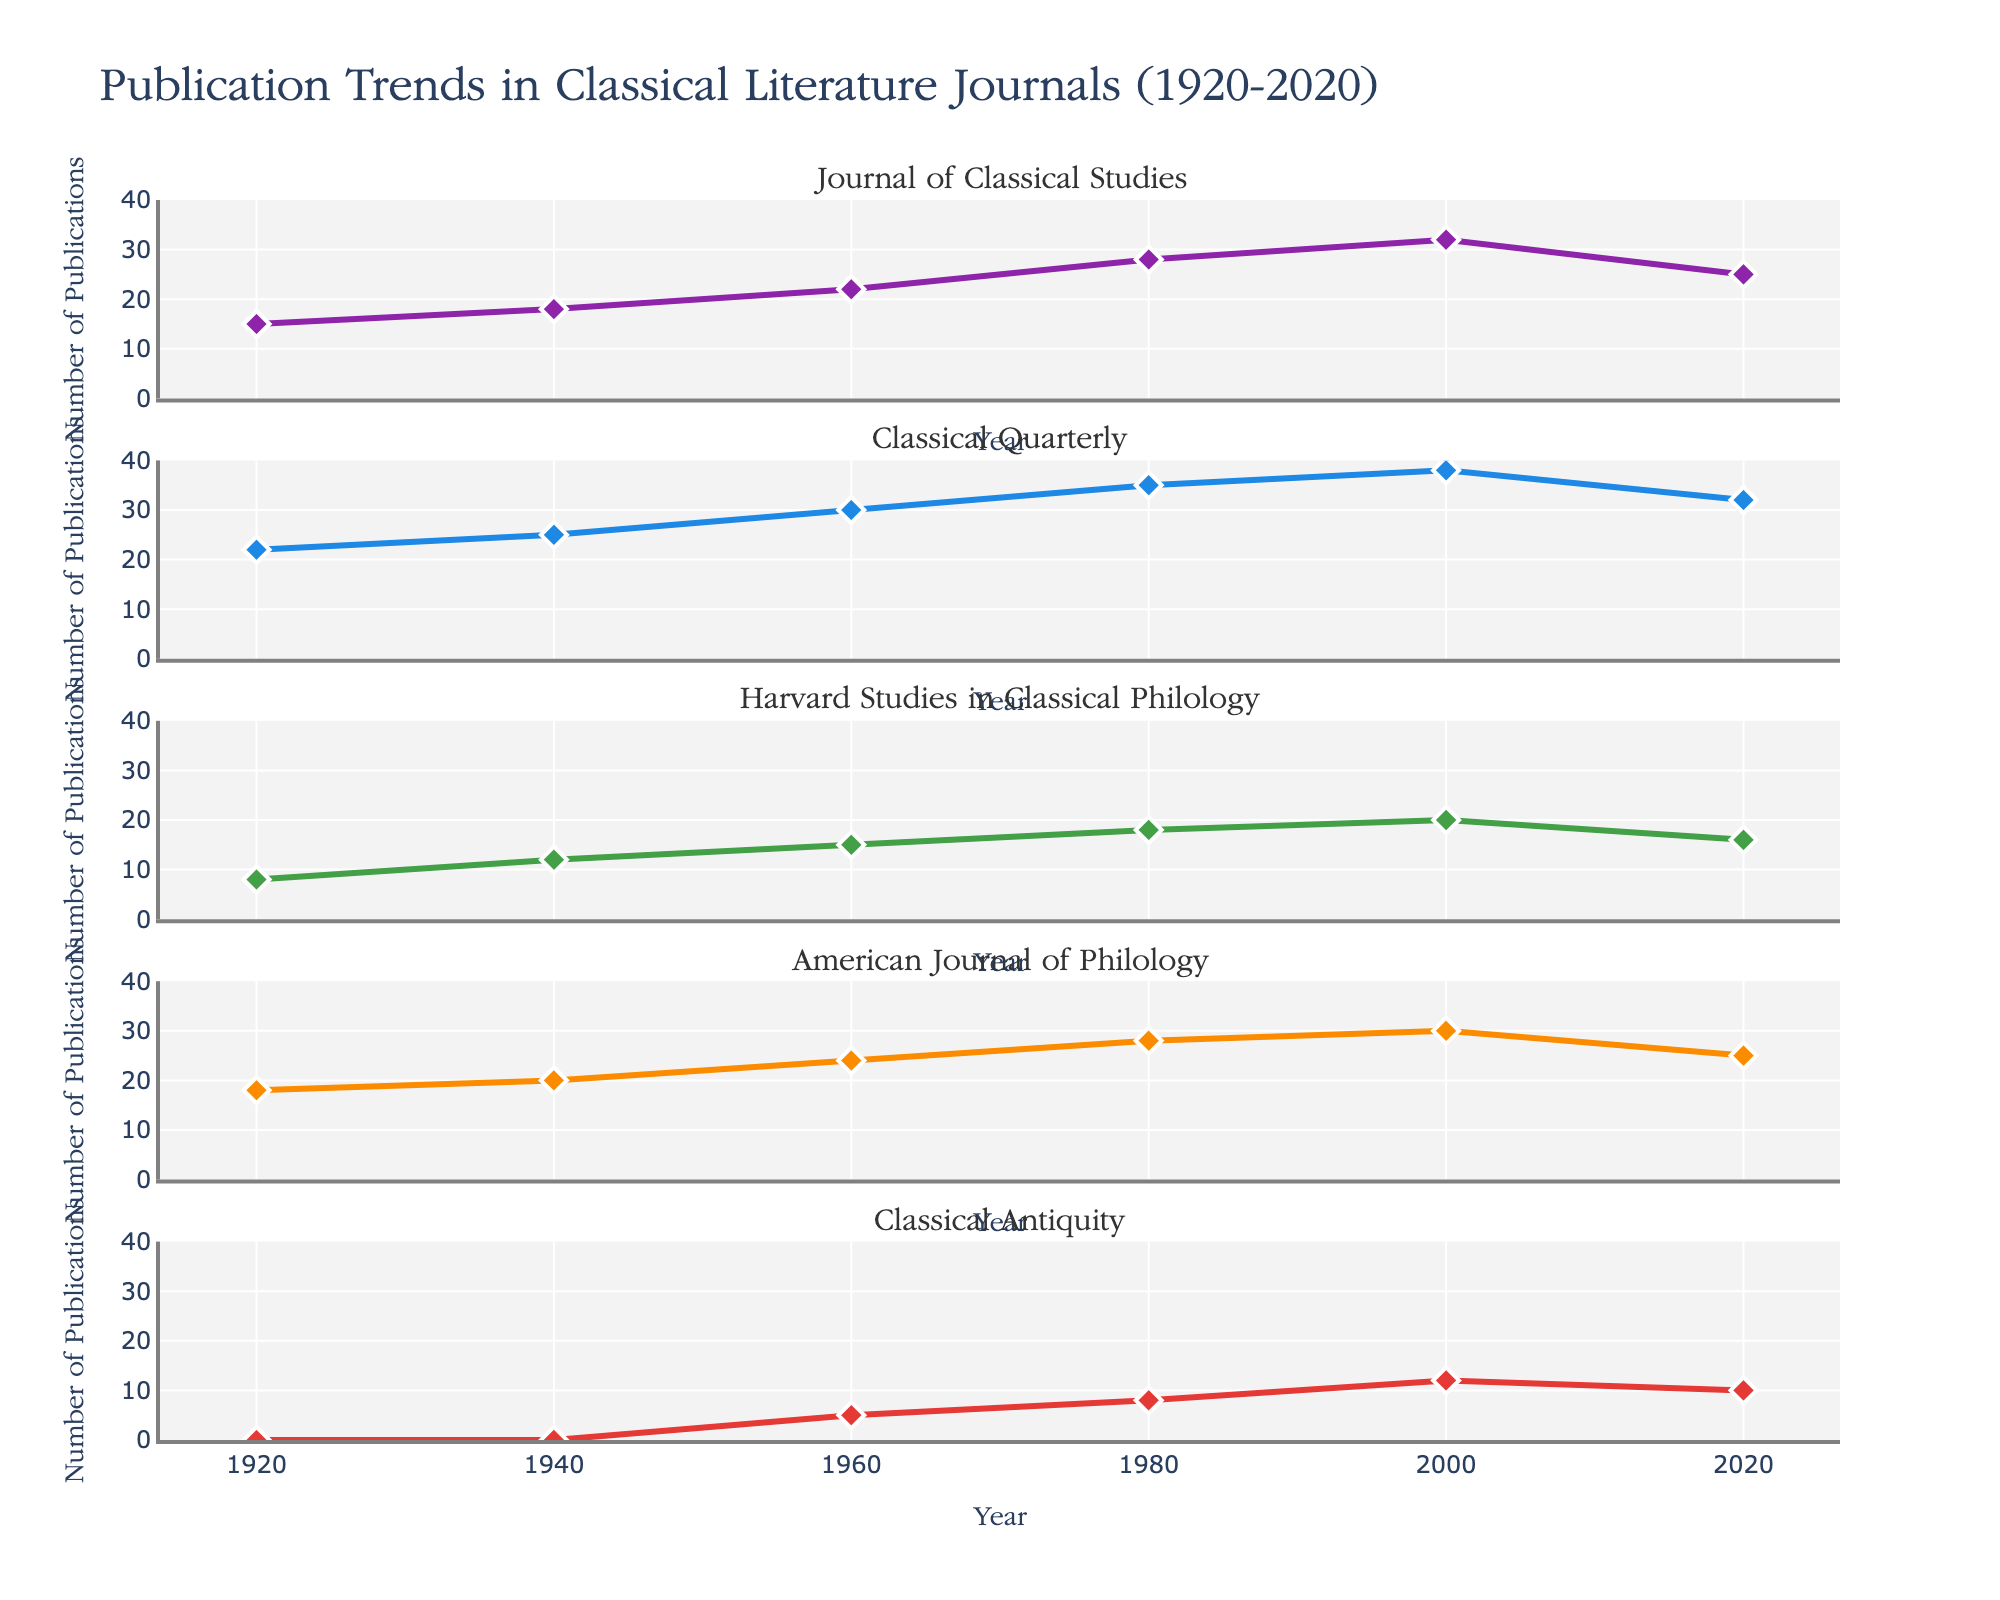what is the title of the figure? The title can be found at the top of the figure, where it usually provides a summary of the visualized data.
Answer: Burke Family Occupations Across Generations How many different occupations are represented in the 1st Generation? The pie chart representing the 1st Generation shows various slices, each corresponding to a distinct occupation. By counting these slices, we can determine the number of occupations.
Answer: 4 Which generation has the highest percentage of a single occupation? To identify which generation has the highest percentage of a single occupation, compare the largest segment in both the pie chart and the other subplot types for each generation. The pie chart of the 1st Generation shows that the Farmer occupation has the highest percentage among all generations.
Answer: 1st Generation What is the sum of the counts of occupations for the 3rd Generation? By summing up the 'Count' values for all occupations represented in the scatter plot for the 3rd Generation, we can get the total. The counts are 7 + 4 + 3 + 3 + 2 + 1.
Answer: 20 What are the two occupations with equal counts in the 3rd Generation? The scatter plot of the 3rd Generation shows points that can be examined for their y-values (counts). The occupations with equal y-values of 3 can be identified.
Answer: Engineer and Accountant Which profession is most common in the 2nd Generation? In the bar plot for the 2nd Generation, the height of the bars corresponds to the 'Count'. The tallest bar indicates the most common profession.
Answer: Farmer In the 4th Generation, which occupation has the second-highest count? The treemap for the 4th Generation displays the sizes of rectangles corresponding to counts. The second-largest rectangle indicates the occupation.
Answer: Marketing Manager Compare the number of occupations between the 1st and 4th Generations. Which generation has more? By counting the distinct occupations shown in the pie chart for the 1st Generation and the treemap for the 4th Generation, we can determine the difference. The 1st Generation has 4 occupations, and the 4th Generation has 6.
Answer: 4th Generation Which generation has the largest variety of occupations? To find the generation with the largest variety, count the number of distinct occupations for each generation presented in the various subplot types (pie, bar, scatter, treemap).
Answer: 4th Generation What percentage of the 3rd Generation are Civil Servants? Referring to the scatter plot for the 3rd Generation, the 'Count' of Civil Servants and the total count of all occupations in this generation can be used to calculate the percentage. The count for Civil Servants is 7, and the total is 20. The calculation is (7/20) * 100%.
Answer: 35% 